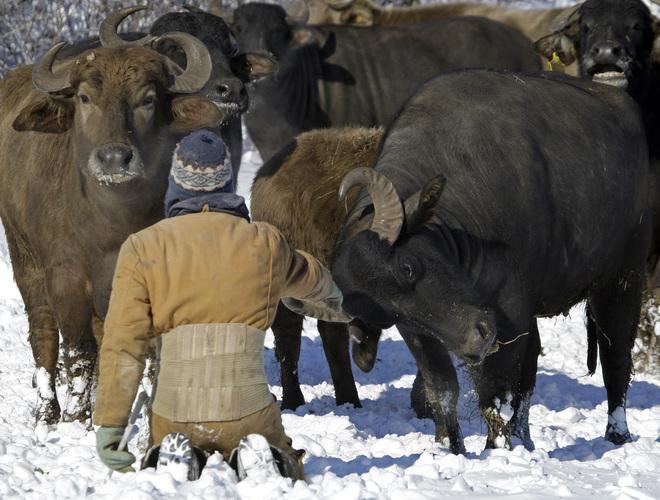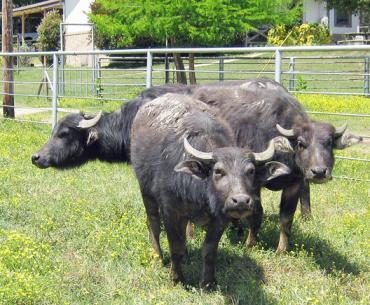The first image is the image on the left, the second image is the image on the right. Analyze the images presented: Is the assertion "At least one image includes a water buffalo in chin-deep water, and the left image includes water buffalo and green grass." valid? Answer yes or no. No. The first image is the image on the left, the second image is the image on the right. Analyze the images presented: Is the assertion "Some water buffalos are in the water." valid? Answer yes or no. No. 